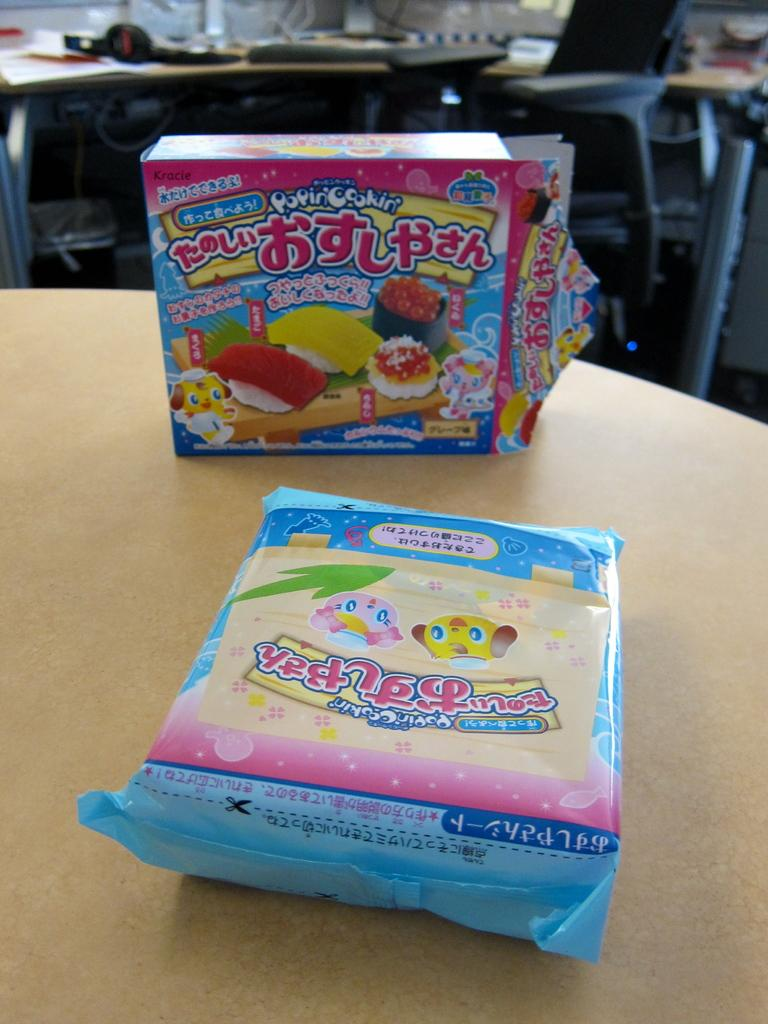What is on the table in the image? There are ice cream packs on a table in the image. Can you describe anything visible in the background of the image? Unfortunately, the provided facts do not give any specific details about the objects visible in the background of the image. How many slaves are visible in the image? There are no slaves present in the image. What type of marble can be seen in the image? There is no marble visible in the image. 